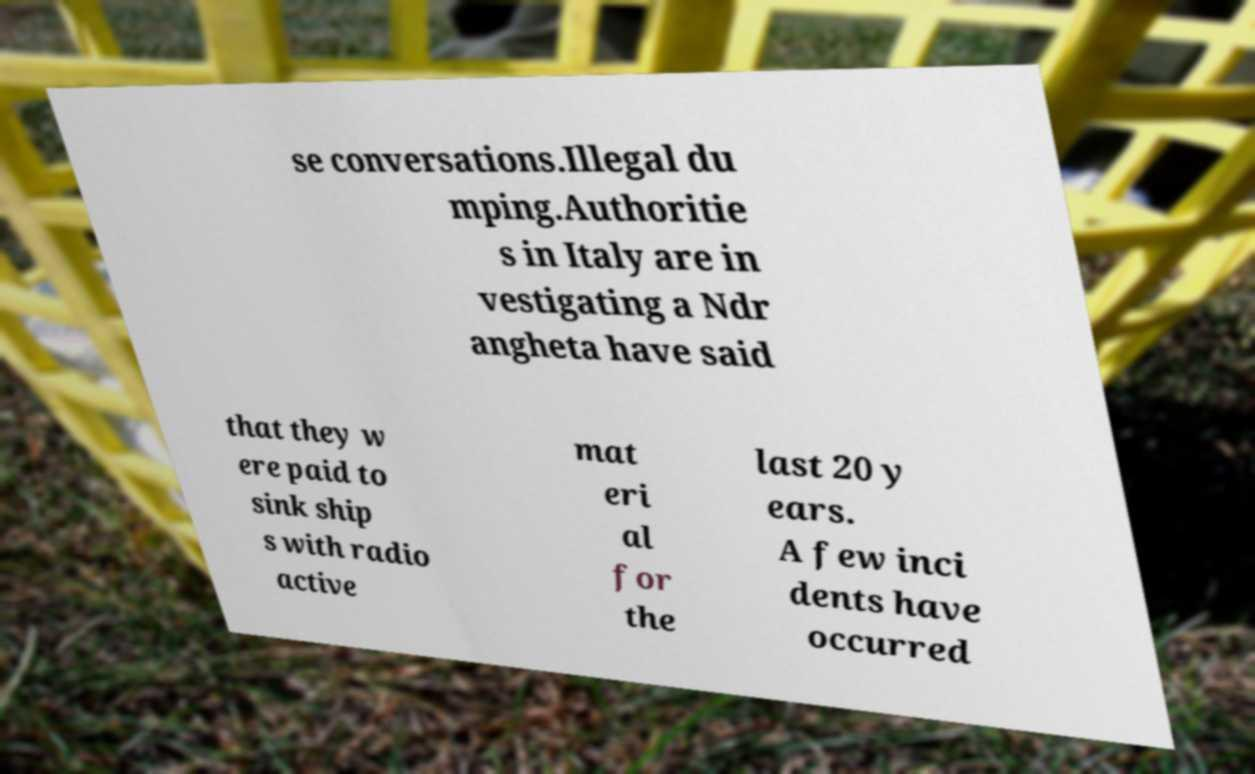Could you assist in decoding the text presented in this image and type it out clearly? se conversations.Illegal du mping.Authoritie s in Italy are in vestigating a Ndr angheta have said that they w ere paid to sink ship s with radio active mat eri al for the last 20 y ears. A few inci dents have occurred 